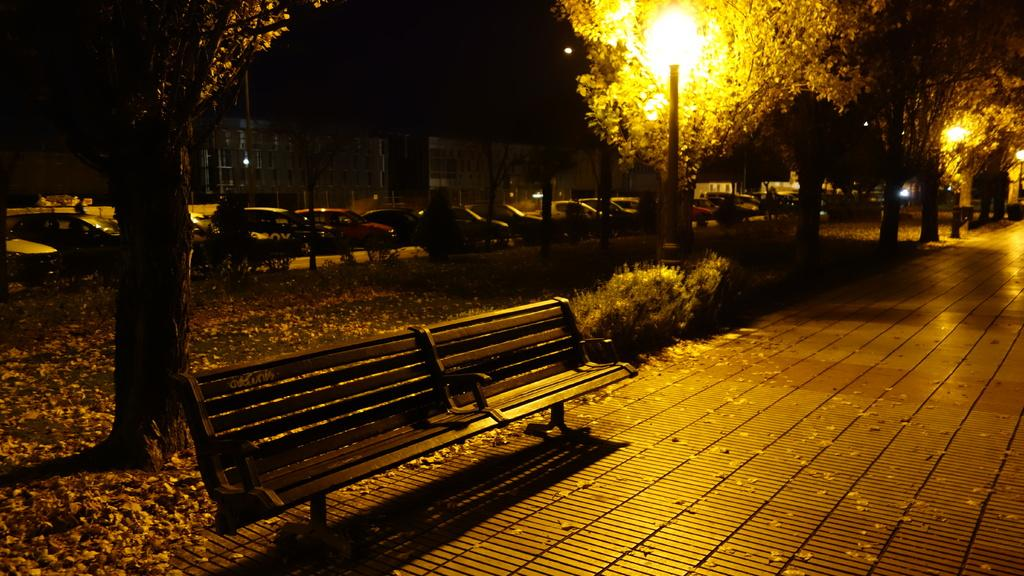What can be seen parked in the image? There are cars parked in the image. What type of vegetation is present in the image? There are trees and plants in the image. What type of seating is available in the image? There is a bench in the image. What type of lighting is present in the image? There are pole lights in the image. What is present on the ground in the image? There are leaves on the ground in the image. Where is the market located in the image? There is no market present in the image. Can you tell me how many babies are crawling on the bench in the image? There are no babies present in the image; only cars, trees, plants, a bench, pole lights, and leaves on the ground are visible. 